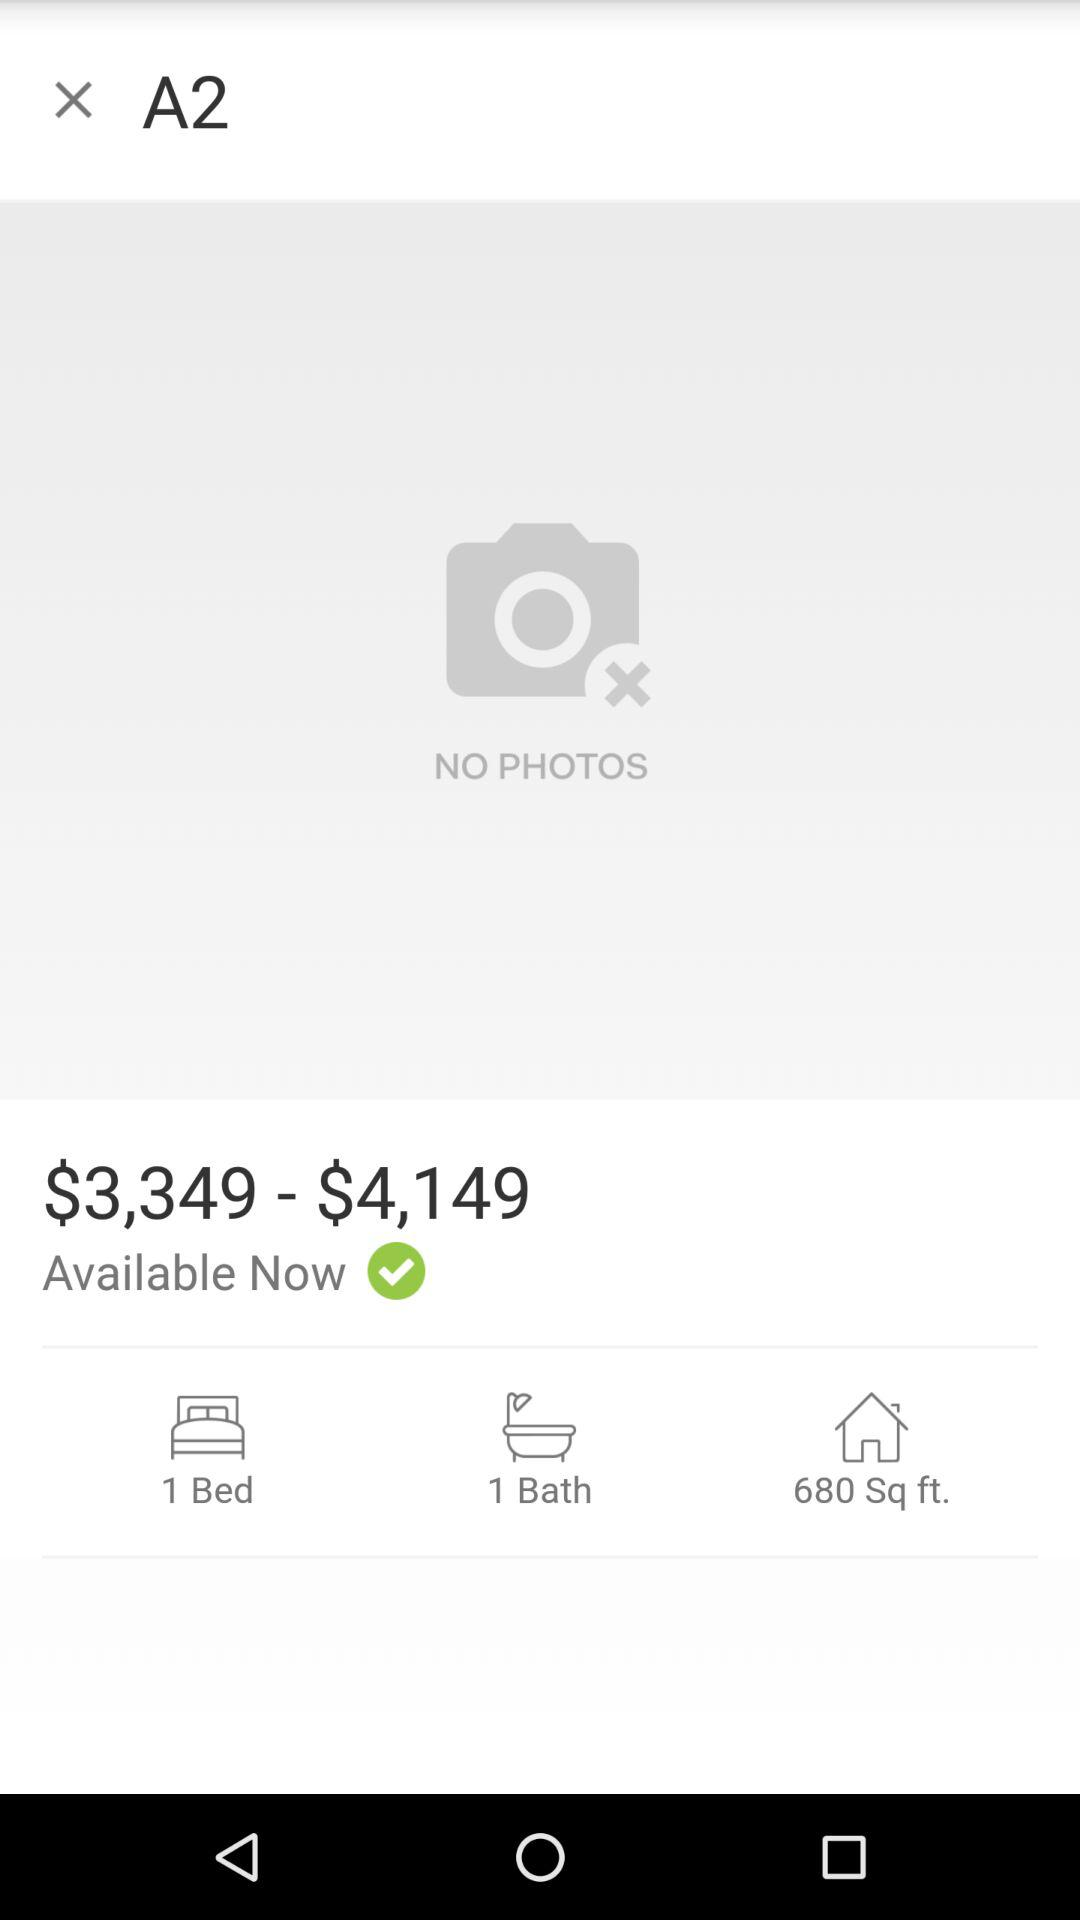What is the number of bathrooms? The number of bathrooms is 1. 